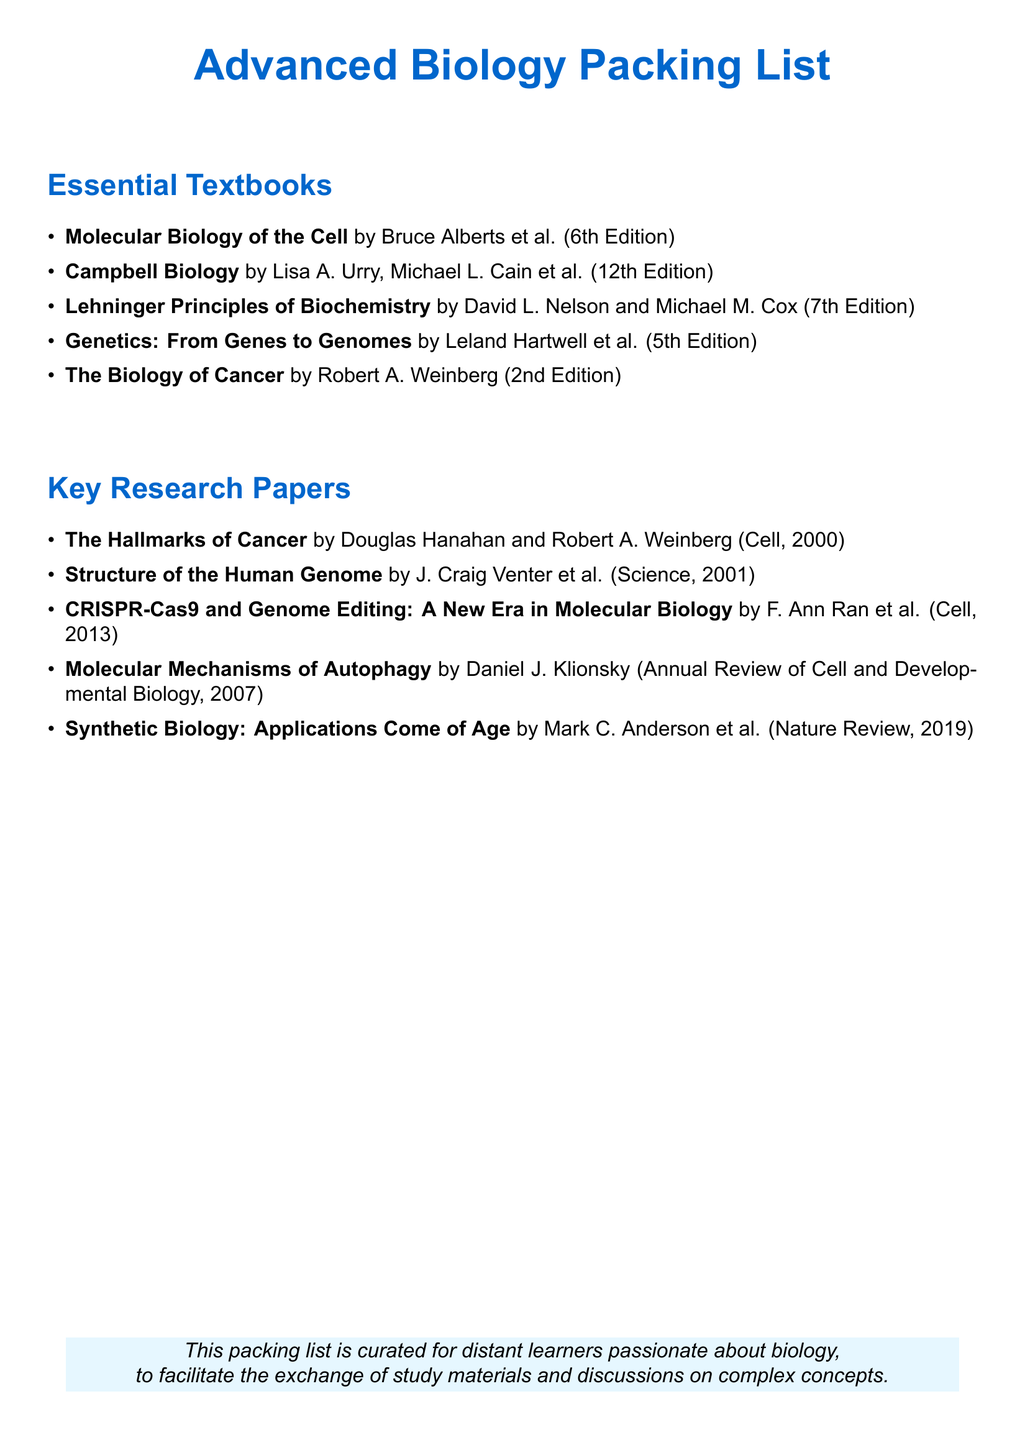What is the title of the textbook by Bruce Alberts? The title is listed under Essential Textbooks as "Molecular Biology of the Cell."
Answer: Molecular Biology of the Cell Who are the authors of "Campbell Biology"? The authors of "Campbell Biology" are Lisa A. Urry, Michael L. Cain et al.
Answer: Lisa A. Urry, Michael L. Cain et al What is the edition of "Lehninger Principles of Biochemistry"? The edition is specified in the list as the 7th Edition.
Answer: 7th Edition What year was "The Hallmarks of Cancer" published? This research paper was published in the year 2000 as mentioned next to its title.
Answer: 2000 How many papers are listed under Key Research Papers? The total number of research papers provided is counted in the document.
Answer: 5 Which research paper focuses on genome editing? The document mentions "CRISPR-Cas9 and Genome Editing: A New Era in Molecular Biology" as a key paper related to genome editing.
Answer: CRISPR-Cas9 and Genome Editing: A New Era in Molecular Biology What is the primary purpose of this packing list? The purpose is stated in the concluding section of the document, emphasizing its function for distant learners.
Answer: Facilitate the exchange of study materials and discussions on complex concepts Which textbook has a focus on cancer biology? The title "The Biology of Cancer" by Robert A. Weinberg is identified in the list.
Answer: The Biology of Cancer What is the publication year of the paper "Synthetic Biology: Applications Come of Age"? The year of publication is stated next to the title as 2019.
Answer: 2019 